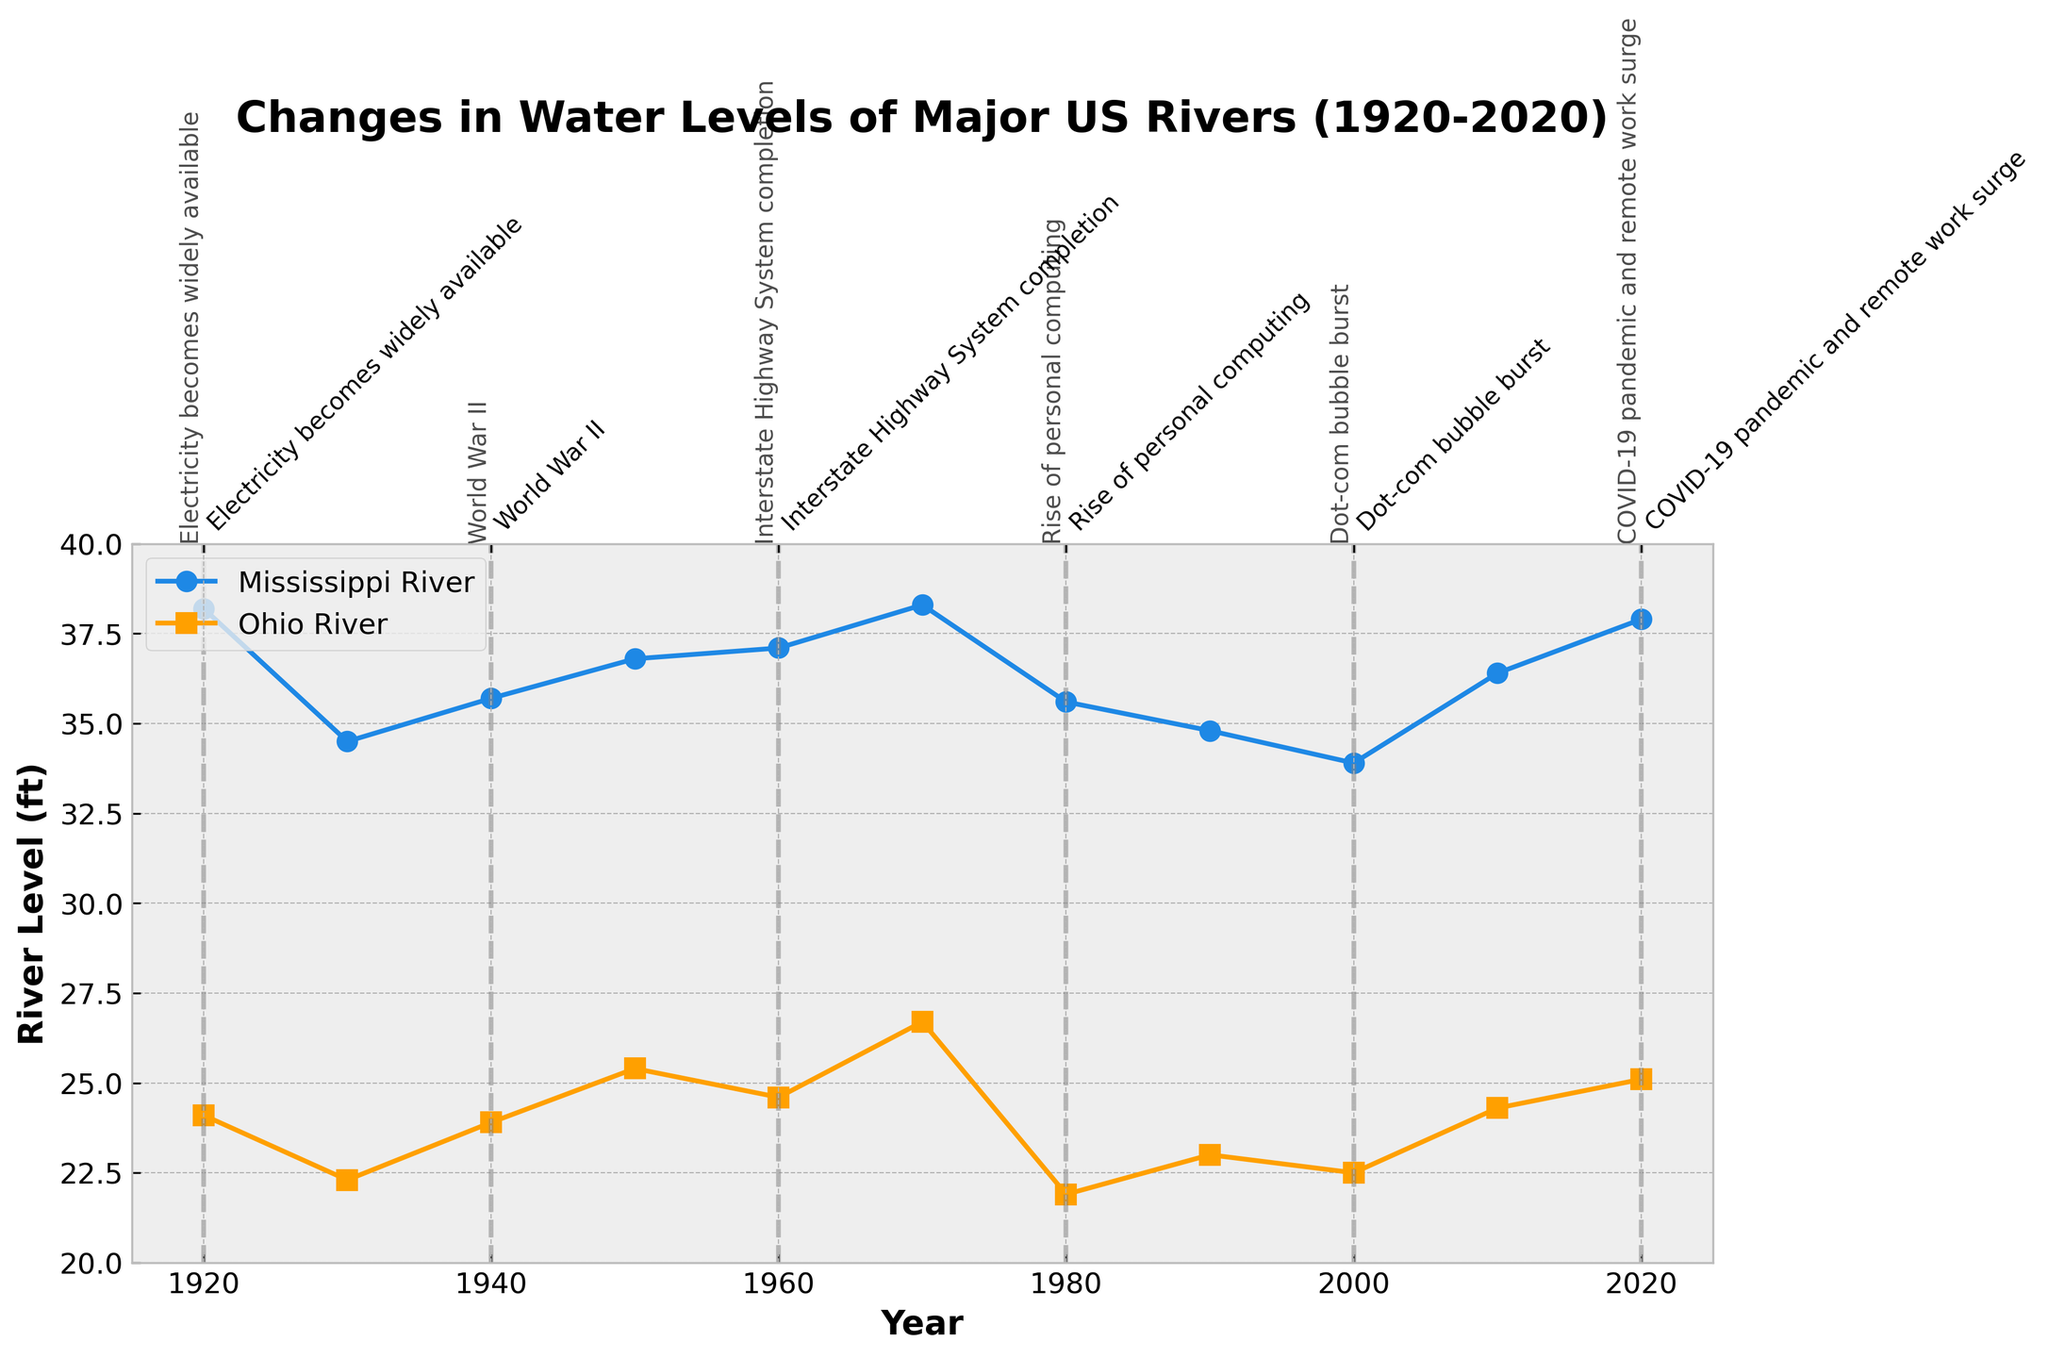what is the title of the figure? The title is usually found at the top of the figure, and it describes the overall content. From the data and code, we know the title is "Changes in Water Levels of Major US Rivers (1920-2020)".
Answer: Changes in Water Levels of Major US Rivers (1920-2020) Which river had a higher water level in 1970? To answer this, locate the year 1970 on the x-axis, then compare the values for the Mississippi and Ohio rivers on the y-axis. In 1970, Mississippi River had 38.3 ft, and Ohio River had 26.7 ft.
Answer: Mississippi River What are the units of measurement for the river levels? Units of measurement for river levels are found on the y-axis label. The figure shows the y-axis labeled as "River Level (ft)", indicating the values are in feet.
Answer: feet What was the water level of the Mississippi River just after the Great Depression? The Great Depression is marked at 1930. Refer to the data point for the Mississippi River in 1930 from the plot, which is 34.5 ft.
Answer: 34.5 ft How did the Ohio River level change between the year of the establishment of the EPA and the rise of personal computing? Locate the years for the establishment of the EPA (1970) and the rise of personal computing (1980). The Ohio River level changed from 26.7 ft in 1970 to 21.9 ft in 1980.
Answer: Decreased by 4.8 ft What was the average water level of the Ohio River in the periods when world wars are marked? Identify the World War periods in the plot: 1940 (WWII). The Ohio River levels during this period were 23.9 ft. Since only one point is given, the average is the same value.
Answer: 23.9 ft Which river shows a more significant fluctuation in water levels between 1920 and 2020? Calculate the difference between the maximum and minimum values for each river over the period. For the Mississippi River, the range is from 33.9 to 38.3 ft; for the Ohio River, it's from 21.9 to 26.7 ft. The Mississippi River shows a more significant fluctuation.
Answer: Mississippi River How did the water levels in each river change from 2000 to 2020? Compare the 2000 and 2020 water levels for both rivers. For the Mississippi River: increased from 33.9 ft to 37.9 ft. For the Ohio River: increased from 22.5 ft to 25.1 ft.
Answer: Both rivers increased Is there any visible impact of industrial milestones on the river levels? Match the river level trends with the corresponding industrial milestones. For instance, after "Post-War Economic Boom" (1950), levels of both rivers trend upwards around 1960 and 1970, suggesting potential impacts.
Answer: Yes, visible impacts 